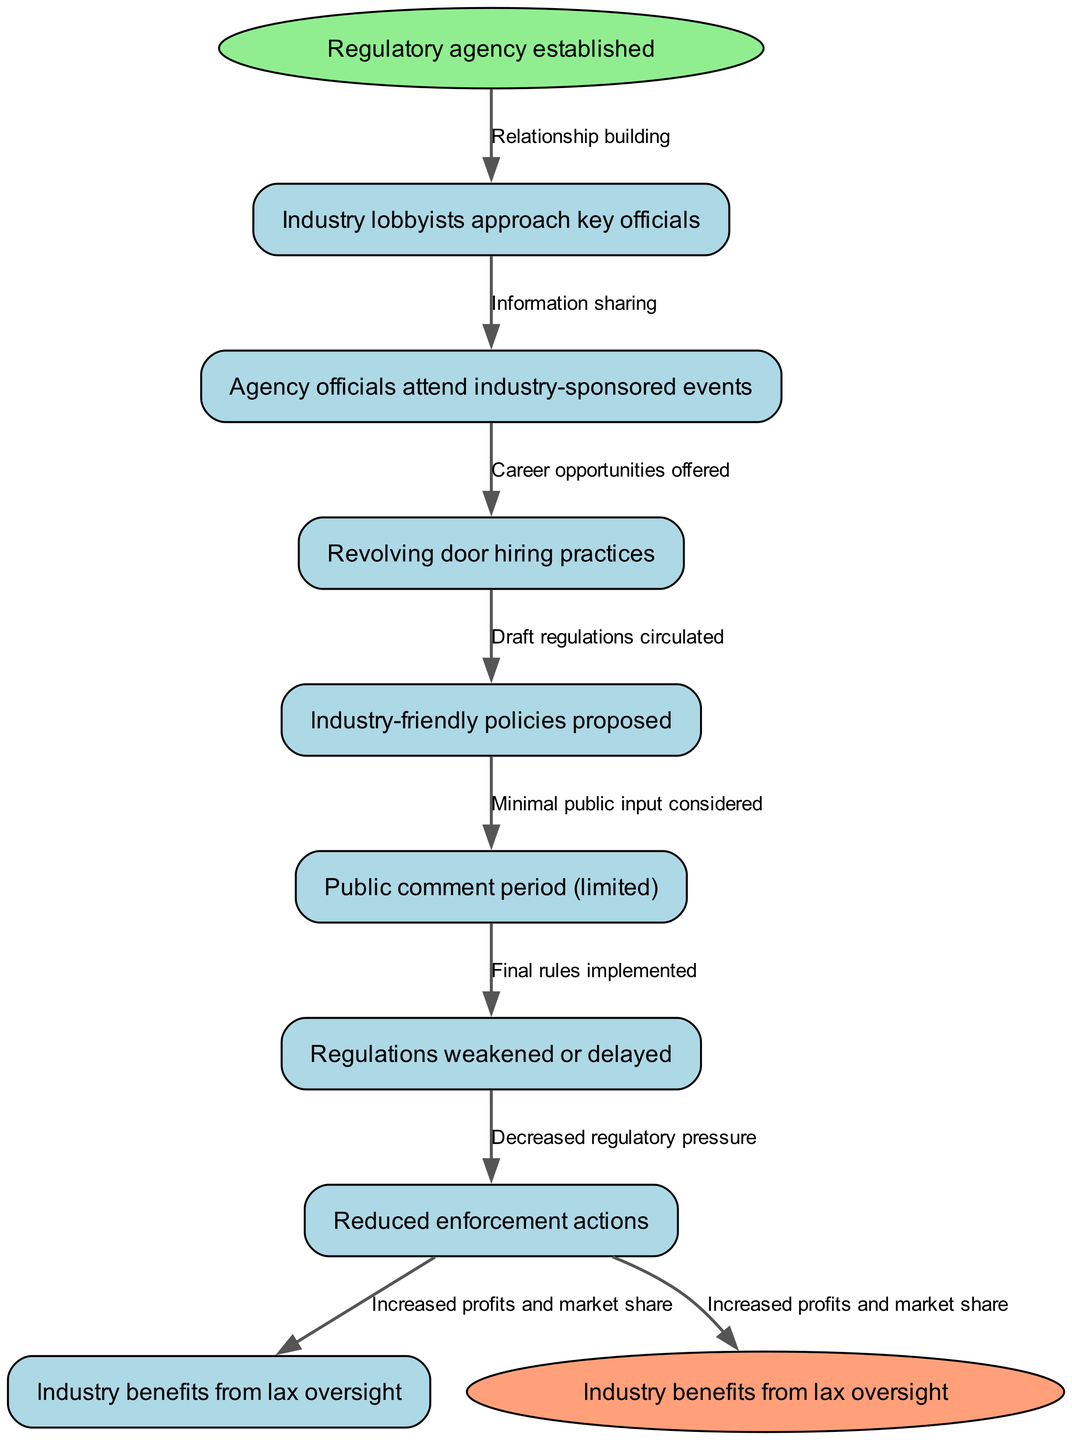What is the starting node of the diagram? The starting node is indicated as "Regulatory agency established," which is the first element in the flow chart.
Answer: Regulatory agency established How many nodes are in the diagram? The diagram consists of a total of 8 nodes, including both the start and end nodes, as listed in the provided data.
Answer: 8 What connects "Agency officials attend industry-sponsored events" to "Revolving door hiring practices"? The connection between these two nodes is represented by the edge labeled "Information sharing," indicating the flow of influence from attending events to hiring practices.
Answer: Information sharing What is the last node in the diagram? The last node is identified as "Industry benefits from lax oversight," which signifies the end of the regulatory capture process in the flow chart.
Answer: Industry benefits from lax oversight Which edge connects "Industry-friendly policies proposed" to "Public comment period (limited)"? The edge connecting these two nodes is labeled "Draft regulations circulated," showing the action taken to transition from policies to public feedback.
Answer: Draft regulations circulated What is the relationship between "Reduced enforcement actions" and "Increased profits and market share"? The relationship is indicated by the edge "Decreased regulatory pressure," which implies that reduced enforcement leads to increased industry benefits.
Answer: Decreased regulatory pressure Which node is directly preceded by "Industry lobbyists approach key officials"? The node that follows directly after "Industry lobbyists approach key officials" is "Agency officials attend industry-sponsored events," indicating the next step in the flow of the process.
Answer: Agency officials attend industry-sponsored events What type of hiring practice does the diagram mention? The diagram specifies "Revolving door hiring practices," indicating that there is a cycle of personnel movement between the industry and the regulatory agency.
Answer: Revolving door hiring practices 